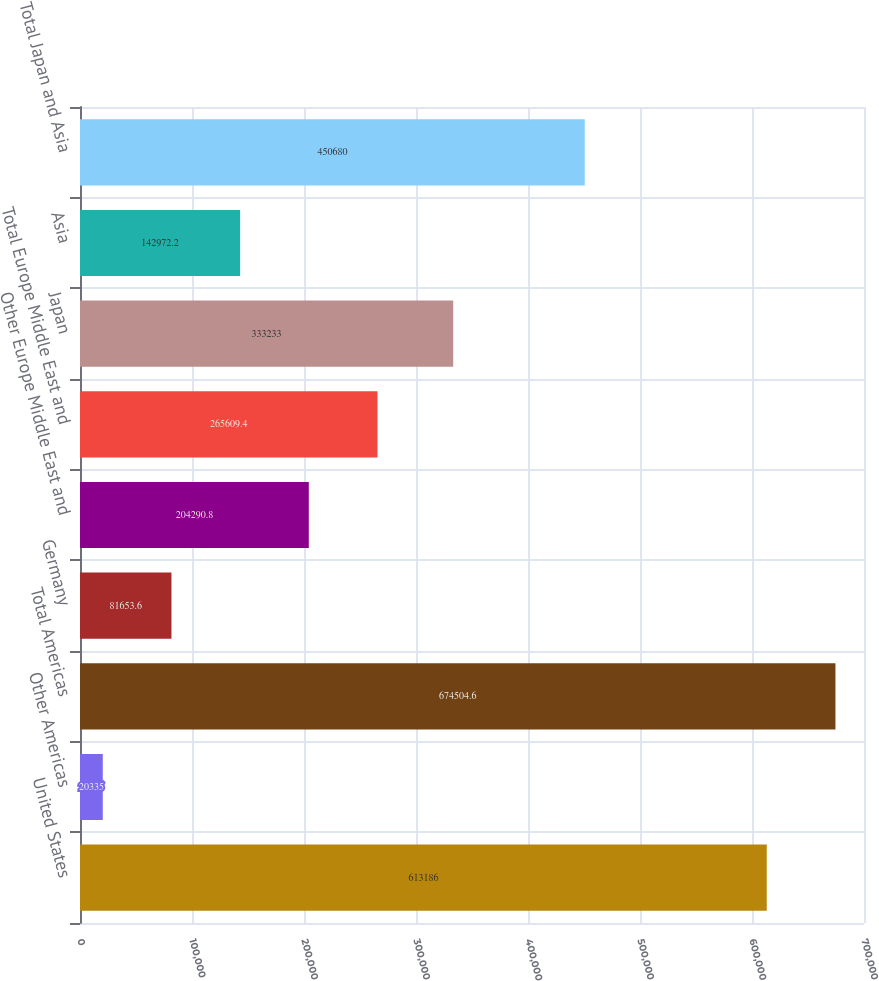Convert chart. <chart><loc_0><loc_0><loc_500><loc_500><bar_chart><fcel>United States<fcel>Other Americas<fcel>Total Americas<fcel>Germany<fcel>Other Europe Middle East and<fcel>Total Europe Middle East and<fcel>Japan<fcel>Asia<fcel>Total Japan and Asia<nl><fcel>613186<fcel>20335<fcel>674505<fcel>81653.6<fcel>204291<fcel>265609<fcel>333233<fcel>142972<fcel>450680<nl></chart> 